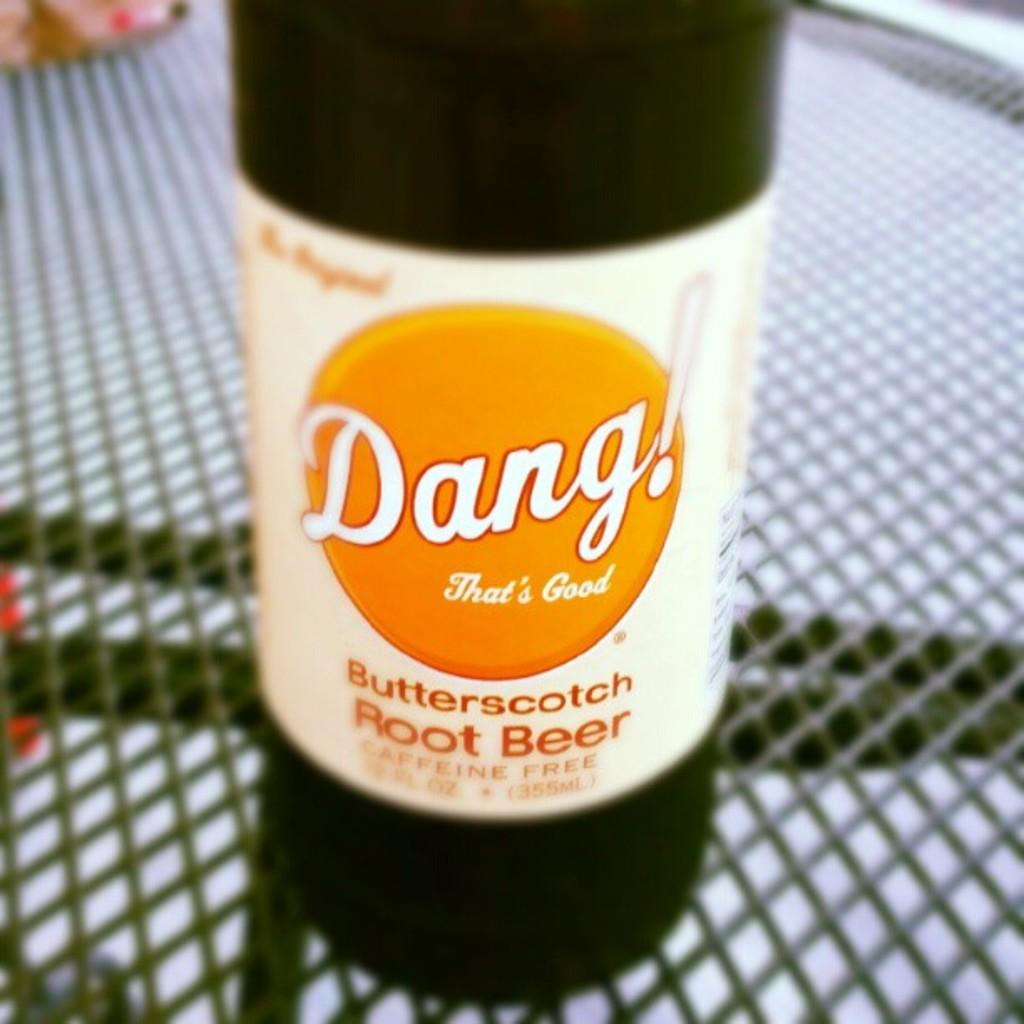<image>
Summarize the visual content of the image. A bottle of Dang! butterscotch decaffeinated root beer 